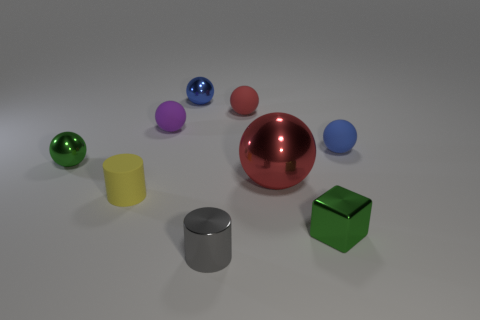Is the size of the shiny thing on the left side of the purple ball the same as the yellow cylinder?
Ensure brevity in your answer.  Yes. There is a small green object that is right of the small matte cylinder; what is it made of?
Make the answer very short. Metal. Are there the same number of yellow objects to the left of the rubber cylinder and tiny things to the right of the green ball?
Offer a terse response. No. There is a large metallic object that is the same shape as the small red rubber object; what color is it?
Your response must be concise. Red. Are there any other things that have the same color as the small matte cylinder?
Offer a terse response. No. What number of rubber objects are small purple things or cylinders?
Make the answer very short. 2. Do the tiny metal block and the large object have the same color?
Provide a short and direct response. No. Are there more small green blocks behind the tiny red matte thing than small yellow spheres?
Keep it short and to the point. No. How many other things are the same material as the small gray cylinder?
Provide a succinct answer. 4. How many small things are either cylinders or gray cylinders?
Your response must be concise. 2. 